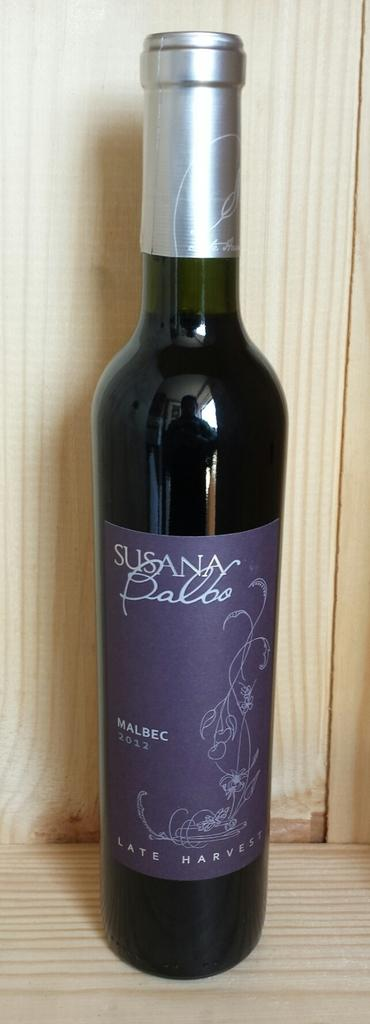<image>
Write a terse but informative summary of the picture. A bottle of red wine with the word Susana on it. 